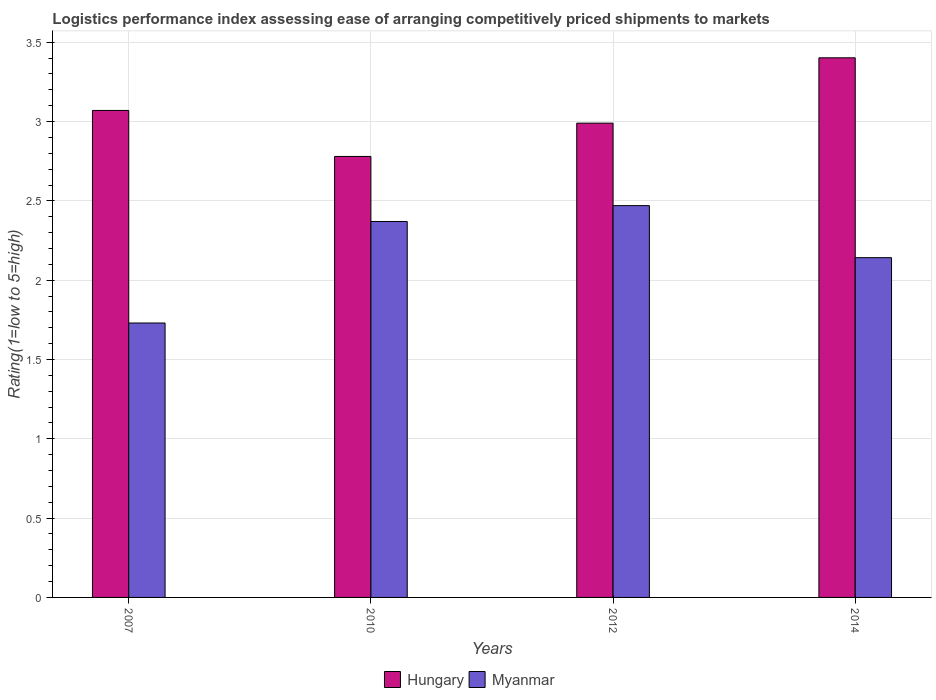How many different coloured bars are there?
Provide a succinct answer. 2. Are the number of bars per tick equal to the number of legend labels?
Offer a terse response. Yes. How many bars are there on the 3rd tick from the right?
Provide a succinct answer. 2. In how many cases, is the number of bars for a given year not equal to the number of legend labels?
Make the answer very short. 0. What is the Logistic performance index in Myanmar in 2007?
Make the answer very short. 1.73. Across all years, what is the maximum Logistic performance index in Hungary?
Your answer should be very brief. 3.4. Across all years, what is the minimum Logistic performance index in Hungary?
Your answer should be very brief. 2.78. In which year was the Logistic performance index in Myanmar minimum?
Your answer should be very brief. 2007. What is the total Logistic performance index in Myanmar in the graph?
Provide a succinct answer. 8.71. What is the difference between the Logistic performance index in Myanmar in 2007 and that in 2012?
Provide a succinct answer. -0.74. What is the difference between the Logistic performance index in Myanmar in 2014 and the Logistic performance index in Hungary in 2012?
Your response must be concise. -0.85. What is the average Logistic performance index in Hungary per year?
Give a very brief answer. 3.06. In the year 2014, what is the difference between the Logistic performance index in Myanmar and Logistic performance index in Hungary?
Provide a short and direct response. -1.26. In how many years, is the Logistic performance index in Hungary greater than 0.1?
Provide a short and direct response. 4. What is the ratio of the Logistic performance index in Myanmar in 2010 to that in 2014?
Ensure brevity in your answer.  1.11. Is the difference between the Logistic performance index in Myanmar in 2012 and 2014 greater than the difference between the Logistic performance index in Hungary in 2012 and 2014?
Make the answer very short. Yes. What is the difference between the highest and the second highest Logistic performance index in Myanmar?
Give a very brief answer. 0.1. What is the difference between the highest and the lowest Logistic performance index in Myanmar?
Give a very brief answer. 0.74. In how many years, is the Logistic performance index in Myanmar greater than the average Logistic performance index in Myanmar taken over all years?
Your response must be concise. 2. Is the sum of the Logistic performance index in Myanmar in 2007 and 2012 greater than the maximum Logistic performance index in Hungary across all years?
Give a very brief answer. Yes. What does the 2nd bar from the left in 2007 represents?
Offer a terse response. Myanmar. What does the 2nd bar from the right in 2007 represents?
Provide a succinct answer. Hungary. How many years are there in the graph?
Your answer should be very brief. 4. What is the difference between two consecutive major ticks on the Y-axis?
Your answer should be very brief. 0.5. Are the values on the major ticks of Y-axis written in scientific E-notation?
Give a very brief answer. No. Does the graph contain any zero values?
Your answer should be very brief. No. Does the graph contain grids?
Provide a short and direct response. Yes. How are the legend labels stacked?
Provide a short and direct response. Horizontal. What is the title of the graph?
Your response must be concise. Logistics performance index assessing ease of arranging competitively priced shipments to markets. Does "Middle East & North Africa (developing only)" appear as one of the legend labels in the graph?
Your answer should be very brief. No. What is the label or title of the Y-axis?
Give a very brief answer. Rating(1=low to 5=high). What is the Rating(1=low to 5=high) in Hungary in 2007?
Offer a very short reply. 3.07. What is the Rating(1=low to 5=high) in Myanmar in 2007?
Your answer should be very brief. 1.73. What is the Rating(1=low to 5=high) in Hungary in 2010?
Keep it short and to the point. 2.78. What is the Rating(1=low to 5=high) in Myanmar in 2010?
Your answer should be compact. 2.37. What is the Rating(1=low to 5=high) in Hungary in 2012?
Ensure brevity in your answer.  2.99. What is the Rating(1=low to 5=high) in Myanmar in 2012?
Provide a short and direct response. 2.47. What is the Rating(1=low to 5=high) of Hungary in 2014?
Ensure brevity in your answer.  3.4. What is the Rating(1=low to 5=high) in Myanmar in 2014?
Make the answer very short. 2.14. Across all years, what is the maximum Rating(1=low to 5=high) of Hungary?
Your answer should be very brief. 3.4. Across all years, what is the maximum Rating(1=low to 5=high) in Myanmar?
Provide a succinct answer. 2.47. Across all years, what is the minimum Rating(1=low to 5=high) of Hungary?
Keep it short and to the point. 2.78. Across all years, what is the minimum Rating(1=low to 5=high) in Myanmar?
Provide a short and direct response. 1.73. What is the total Rating(1=low to 5=high) of Hungary in the graph?
Give a very brief answer. 12.24. What is the total Rating(1=low to 5=high) in Myanmar in the graph?
Offer a very short reply. 8.71. What is the difference between the Rating(1=low to 5=high) of Hungary in 2007 and that in 2010?
Provide a short and direct response. 0.29. What is the difference between the Rating(1=low to 5=high) in Myanmar in 2007 and that in 2010?
Offer a terse response. -0.64. What is the difference between the Rating(1=low to 5=high) in Myanmar in 2007 and that in 2012?
Your response must be concise. -0.74. What is the difference between the Rating(1=low to 5=high) of Hungary in 2007 and that in 2014?
Offer a terse response. -0.33. What is the difference between the Rating(1=low to 5=high) of Myanmar in 2007 and that in 2014?
Give a very brief answer. -0.41. What is the difference between the Rating(1=low to 5=high) in Hungary in 2010 and that in 2012?
Give a very brief answer. -0.21. What is the difference between the Rating(1=low to 5=high) in Myanmar in 2010 and that in 2012?
Keep it short and to the point. -0.1. What is the difference between the Rating(1=low to 5=high) in Hungary in 2010 and that in 2014?
Keep it short and to the point. -0.62. What is the difference between the Rating(1=low to 5=high) of Myanmar in 2010 and that in 2014?
Keep it short and to the point. 0.23. What is the difference between the Rating(1=low to 5=high) in Hungary in 2012 and that in 2014?
Provide a short and direct response. -0.41. What is the difference between the Rating(1=low to 5=high) in Myanmar in 2012 and that in 2014?
Make the answer very short. 0.33. What is the difference between the Rating(1=low to 5=high) in Hungary in 2007 and the Rating(1=low to 5=high) in Myanmar in 2010?
Give a very brief answer. 0.7. What is the difference between the Rating(1=low to 5=high) of Hungary in 2007 and the Rating(1=low to 5=high) of Myanmar in 2014?
Provide a succinct answer. 0.93. What is the difference between the Rating(1=low to 5=high) in Hungary in 2010 and the Rating(1=low to 5=high) in Myanmar in 2012?
Provide a succinct answer. 0.31. What is the difference between the Rating(1=low to 5=high) in Hungary in 2010 and the Rating(1=low to 5=high) in Myanmar in 2014?
Give a very brief answer. 0.64. What is the difference between the Rating(1=low to 5=high) in Hungary in 2012 and the Rating(1=low to 5=high) in Myanmar in 2014?
Your response must be concise. 0.85. What is the average Rating(1=low to 5=high) of Hungary per year?
Offer a terse response. 3.06. What is the average Rating(1=low to 5=high) in Myanmar per year?
Your answer should be very brief. 2.18. In the year 2007, what is the difference between the Rating(1=low to 5=high) of Hungary and Rating(1=low to 5=high) of Myanmar?
Your response must be concise. 1.34. In the year 2010, what is the difference between the Rating(1=low to 5=high) in Hungary and Rating(1=low to 5=high) in Myanmar?
Your answer should be compact. 0.41. In the year 2012, what is the difference between the Rating(1=low to 5=high) of Hungary and Rating(1=low to 5=high) of Myanmar?
Provide a short and direct response. 0.52. In the year 2014, what is the difference between the Rating(1=low to 5=high) in Hungary and Rating(1=low to 5=high) in Myanmar?
Offer a very short reply. 1.26. What is the ratio of the Rating(1=low to 5=high) in Hungary in 2007 to that in 2010?
Your answer should be very brief. 1.1. What is the ratio of the Rating(1=low to 5=high) of Myanmar in 2007 to that in 2010?
Make the answer very short. 0.73. What is the ratio of the Rating(1=low to 5=high) of Hungary in 2007 to that in 2012?
Your response must be concise. 1.03. What is the ratio of the Rating(1=low to 5=high) of Myanmar in 2007 to that in 2012?
Offer a terse response. 0.7. What is the ratio of the Rating(1=low to 5=high) of Hungary in 2007 to that in 2014?
Your answer should be compact. 0.9. What is the ratio of the Rating(1=low to 5=high) of Myanmar in 2007 to that in 2014?
Ensure brevity in your answer.  0.81. What is the ratio of the Rating(1=low to 5=high) of Hungary in 2010 to that in 2012?
Offer a very short reply. 0.93. What is the ratio of the Rating(1=low to 5=high) in Myanmar in 2010 to that in 2012?
Provide a short and direct response. 0.96. What is the ratio of the Rating(1=low to 5=high) of Hungary in 2010 to that in 2014?
Make the answer very short. 0.82. What is the ratio of the Rating(1=low to 5=high) in Myanmar in 2010 to that in 2014?
Offer a terse response. 1.11. What is the ratio of the Rating(1=low to 5=high) of Hungary in 2012 to that in 2014?
Provide a short and direct response. 0.88. What is the ratio of the Rating(1=low to 5=high) of Myanmar in 2012 to that in 2014?
Ensure brevity in your answer.  1.15. What is the difference between the highest and the second highest Rating(1=low to 5=high) of Hungary?
Your response must be concise. 0.33. What is the difference between the highest and the second highest Rating(1=low to 5=high) of Myanmar?
Your response must be concise. 0.1. What is the difference between the highest and the lowest Rating(1=low to 5=high) in Hungary?
Your answer should be compact. 0.62. What is the difference between the highest and the lowest Rating(1=low to 5=high) in Myanmar?
Provide a short and direct response. 0.74. 